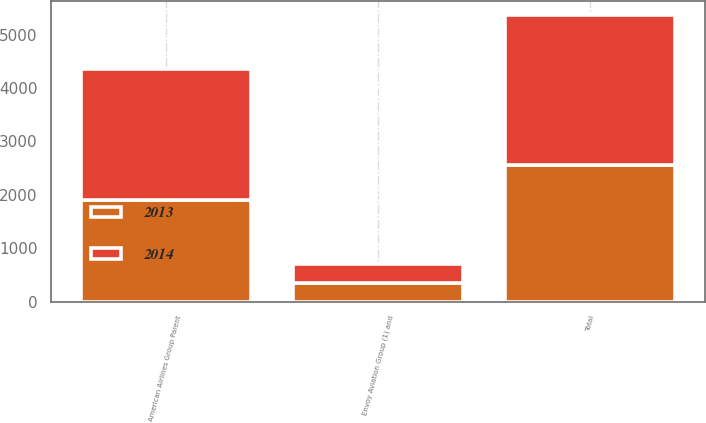<chart> <loc_0><loc_0><loc_500><loc_500><stacked_bar_chart><ecel><fcel>American Airlines Group Parent<fcel>Envoy Aviation Group (1) and<fcel>Total<nl><fcel>2013<fcel>1893<fcel>350<fcel>2563<nl><fcel>2014<fcel>2455<fcel>352<fcel>2807<nl></chart> 